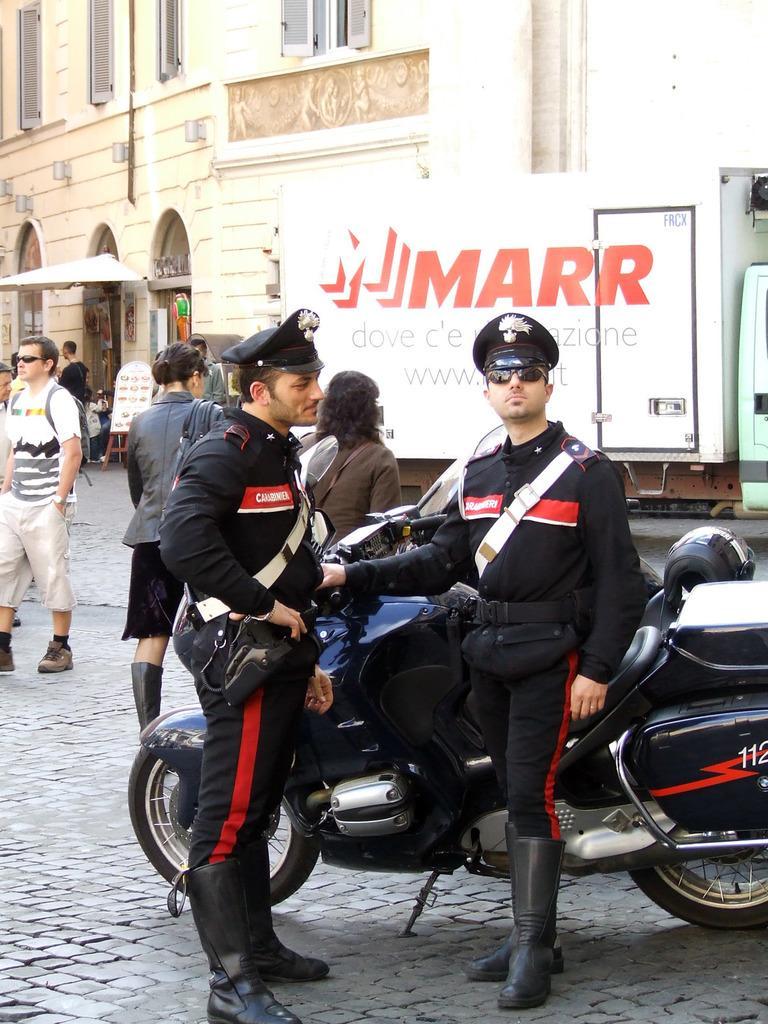Could you give a brief overview of what you see in this image? In the center of the image there are police officers standing near a bike. In the background of the image there is a building. There are windows. There are people walking on the road. In the background of the image there is a truck. 